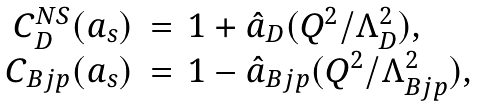<formula> <loc_0><loc_0><loc_500><loc_500>\begin{array} { r c l } { { C _ { D } ^ { N S } ( a _ { s } ) } } & { = } & { { 1 + \hat { a } _ { D } ( Q ^ { 2 } / \Lambda _ { D } ^ { 2 } ) , } } \\ { { C _ { B j p } ( a _ { s } ) } } & { = } & { { 1 - \hat { a } _ { B j p } ( Q ^ { 2 } / \Lambda _ { B j p } ^ { 2 } ) , } } \end{array}</formula> 